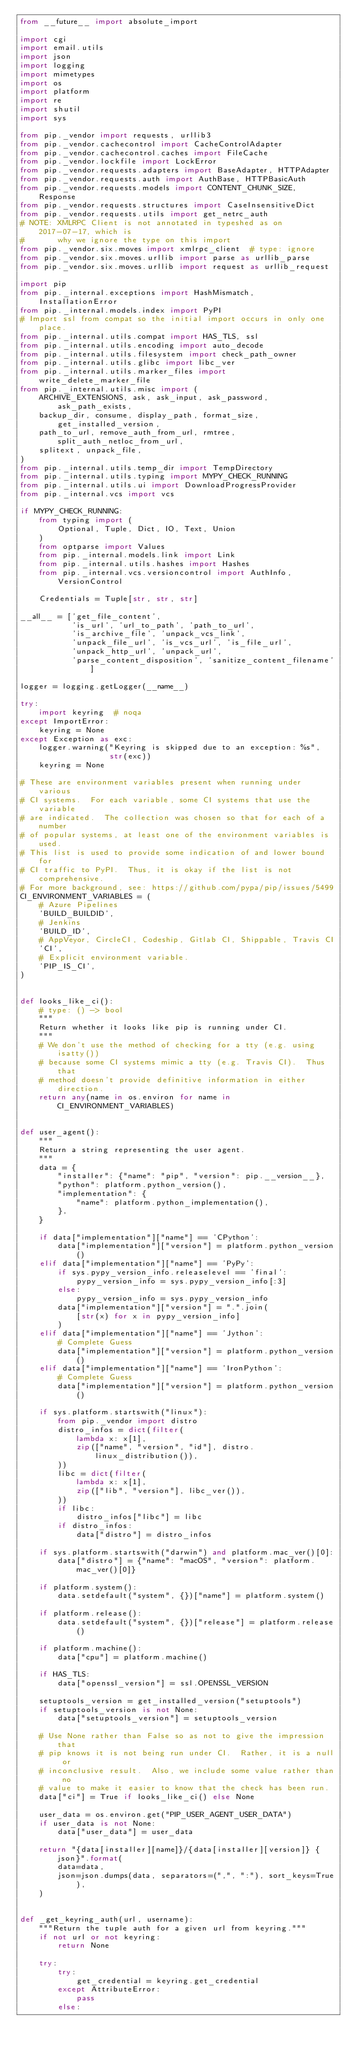<code> <loc_0><loc_0><loc_500><loc_500><_Python_>from __future__ import absolute_import

import cgi
import email.utils
import json
import logging
import mimetypes
import os
import platform
import re
import shutil
import sys

from pip._vendor import requests, urllib3
from pip._vendor.cachecontrol import CacheControlAdapter
from pip._vendor.cachecontrol.caches import FileCache
from pip._vendor.lockfile import LockError
from pip._vendor.requests.adapters import BaseAdapter, HTTPAdapter
from pip._vendor.requests.auth import AuthBase, HTTPBasicAuth
from pip._vendor.requests.models import CONTENT_CHUNK_SIZE, Response
from pip._vendor.requests.structures import CaseInsensitiveDict
from pip._vendor.requests.utils import get_netrc_auth
# NOTE: XMLRPC Client is not annotated in typeshed as on 2017-07-17, which is
#       why we ignore the type on this import
from pip._vendor.six.moves import xmlrpc_client  # type: ignore
from pip._vendor.six.moves.urllib import parse as urllib_parse
from pip._vendor.six.moves.urllib import request as urllib_request

import pip
from pip._internal.exceptions import HashMismatch, InstallationError
from pip._internal.models.index import PyPI
# Import ssl from compat so the initial import occurs in only one place.
from pip._internal.utils.compat import HAS_TLS, ssl
from pip._internal.utils.encoding import auto_decode
from pip._internal.utils.filesystem import check_path_owner
from pip._internal.utils.glibc import libc_ver
from pip._internal.utils.marker_files import write_delete_marker_file
from pip._internal.utils.misc import (
    ARCHIVE_EXTENSIONS, ask, ask_input, ask_password, ask_path_exists,
    backup_dir, consume, display_path, format_size, get_installed_version,
    path_to_url, remove_auth_from_url, rmtree, split_auth_netloc_from_url,
    splitext, unpack_file,
)
from pip._internal.utils.temp_dir import TempDirectory
from pip._internal.utils.typing import MYPY_CHECK_RUNNING
from pip._internal.utils.ui import DownloadProgressProvider
from pip._internal.vcs import vcs

if MYPY_CHECK_RUNNING:
    from typing import (
        Optional, Tuple, Dict, IO, Text, Union
    )
    from optparse import Values
    from pip._internal.models.link import Link
    from pip._internal.utils.hashes import Hashes
    from pip._internal.vcs.versioncontrol import AuthInfo, VersionControl

    Credentials = Tuple[str, str, str]

__all__ = ['get_file_content',
           'is_url', 'url_to_path', 'path_to_url',
           'is_archive_file', 'unpack_vcs_link',
           'unpack_file_url', 'is_vcs_url', 'is_file_url',
           'unpack_http_url', 'unpack_url',
           'parse_content_disposition', 'sanitize_content_filename']

logger = logging.getLogger(__name__)

try:
    import keyring  # noqa
except ImportError:
    keyring = None
except Exception as exc:
    logger.warning("Keyring is skipped due to an exception: %s",
                   str(exc))
    keyring = None

# These are environment variables present when running under various
# CI systems.  For each variable, some CI systems that use the variable
# are indicated.  The collection was chosen so that for each of a number
# of popular systems, at least one of the environment variables is used.
# This list is used to provide some indication of and lower bound for
# CI traffic to PyPI.  Thus, it is okay if the list is not comprehensive.
# For more background, see: https://github.com/pypa/pip/issues/5499
CI_ENVIRONMENT_VARIABLES = (
    # Azure Pipelines
    'BUILD_BUILDID',
    # Jenkins
    'BUILD_ID',
    # AppVeyor, CircleCI, Codeship, Gitlab CI, Shippable, Travis CI
    'CI',
    # Explicit environment variable.
    'PIP_IS_CI',
)


def looks_like_ci():
    # type: () -> bool
    """
    Return whether it looks like pip is running under CI.
    """
    # We don't use the method of checking for a tty (e.g. using isatty())
    # because some CI systems mimic a tty (e.g. Travis CI).  Thus that
    # method doesn't provide definitive information in either direction.
    return any(name in os.environ for name in CI_ENVIRONMENT_VARIABLES)


def user_agent():
    """
    Return a string representing the user agent.
    """
    data = {
        "installer": {"name": "pip", "version": pip.__version__},
        "python": platform.python_version(),
        "implementation": {
            "name": platform.python_implementation(),
        },
    }

    if data["implementation"]["name"] == 'CPython':
        data["implementation"]["version"] = platform.python_version()
    elif data["implementation"]["name"] == 'PyPy':
        if sys.pypy_version_info.releaselevel == 'final':
            pypy_version_info = sys.pypy_version_info[:3]
        else:
            pypy_version_info = sys.pypy_version_info
        data["implementation"]["version"] = ".".join(
            [str(x) for x in pypy_version_info]
        )
    elif data["implementation"]["name"] == 'Jython':
        # Complete Guess
        data["implementation"]["version"] = platform.python_version()
    elif data["implementation"]["name"] == 'IronPython':
        # Complete Guess
        data["implementation"]["version"] = platform.python_version()

    if sys.platform.startswith("linux"):
        from pip._vendor import distro
        distro_infos = dict(filter(
            lambda x: x[1],
            zip(["name", "version", "id"], distro.linux_distribution()),
        ))
        libc = dict(filter(
            lambda x: x[1],
            zip(["lib", "version"], libc_ver()),
        ))
        if libc:
            distro_infos["libc"] = libc
        if distro_infos:
            data["distro"] = distro_infos

    if sys.platform.startswith("darwin") and platform.mac_ver()[0]:
        data["distro"] = {"name": "macOS", "version": platform.mac_ver()[0]}

    if platform.system():
        data.setdefault("system", {})["name"] = platform.system()

    if platform.release():
        data.setdefault("system", {})["release"] = platform.release()

    if platform.machine():
        data["cpu"] = platform.machine()

    if HAS_TLS:
        data["openssl_version"] = ssl.OPENSSL_VERSION

    setuptools_version = get_installed_version("setuptools")
    if setuptools_version is not None:
        data["setuptools_version"] = setuptools_version

    # Use None rather than False so as not to give the impression that
    # pip knows it is not being run under CI.  Rather, it is a null or
    # inconclusive result.  Also, we include some value rather than no
    # value to make it easier to know that the check has been run.
    data["ci"] = True if looks_like_ci() else None

    user_data = os.environ.get("PIP_USER_AGENT_USER_DATA")
    if user_data is not None:
        data["user_data"] = user_data

    return "{data[installer][name]}/{data[installer][version]} {json}".format(
        data=data,
        json=json.dumps(data, separators=(",", ":"), sort_keys=True),
    )


def _get_keyring_auth(url, username):
    """Return the tuple auth for a given url from keyring."""
    if not url or not keyring:
        return None

    try:
        try:
            get_credential = keyring.get_credential
        except AttributeError:
            pass
        else:</code> 